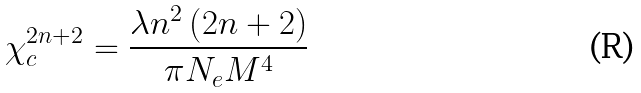<formula> <loc_0><loc_0><loc_500><loc_500>\chi _ { c } ^ { 2 n + 2 } = \frac { \lambda n ^ { 2 } \left ( 2 n + 2 \right ) } { \pi N _ { e } M ^ { 4 } }</formula> 